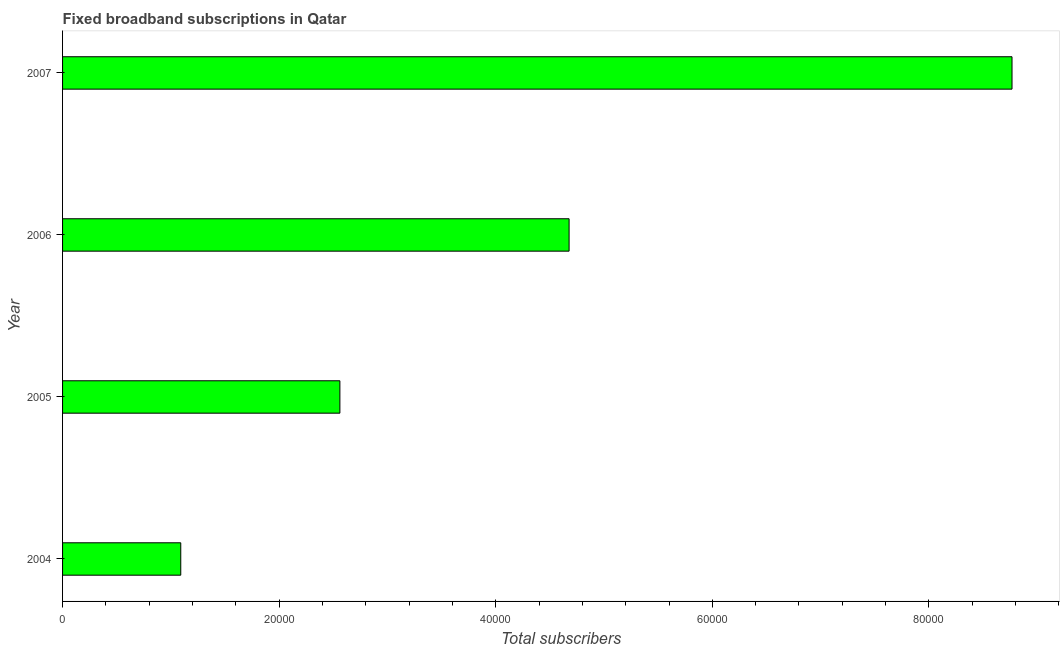Does the graph contain any zero values?
Your answer should be compact. No. Does the graph contain grids?
Keep it short and to the point. No. What is the title of the graph?
Ensure brevity in your answer.  Fixed broadband subscriptions in Qatar. What is the label or title of the X-axis?
Offer a very short reply. Total subscribers. What is the label or title of the Y-axis?
Provide a succinct answer. Year. What is the total number of fixed broadband subscriptions in 2006?
Keep it short and to the point. 4.68e+04. Across all years, what is the maximum total number of fixed broadband subscriptions?
Keep it short and to the point. 8.77e+04. Across all years, what is the minimum total number of fixed broadband subscriptions?
Give a very brief answer. 1.09e+04. What is the sum of the total number of fixed broadband subscriptions?
Offer a terse response. 1.71e+05. What is the difference between the total number of fixed broadband subscriptions in 2005 and 2007?
Provide a short and direct response. -6.21e+04. What is the average total number of fixed broadband subscriptions per year?
Give a very brief answer. 4.27e+04. What is the median total number of fixed broadband subscriptions?
Ensure brevity in your answer.  3.62e+04. In how many years, is the total number of fixed broadband subscriptions greater than 48000 ?
Your response must be concise. 1. Do a majority of the years between 2007 and 2004 (inclusive) have total number of fixed broadband subscriptions greater than 56000 ?
Keep it short and to the point. Yes. What is the ratio of the total number of fixed broadband subscriptions in 2005 to that in 2006?
Your answer should be compact. 0.55. Is the total number of fixed broadband subscriptions in 2004 less than that in 2005?
Give a very brief answer. Yes. What is the difference between the highest and the second highest total number of fixed broadband subscriptions?
Provide a succinct answer. 4.09e+04. What is the difference between the highest and the lowest total number of fixed broadband subscriptions?
Provide a succinct answer. 7.68e+04. In how many years, is the total number of fixed broadband subscriptions greater than the average total number of fixed broadband subscriptions taken over all years?
Your response must be concise. 2. How many bars are there?
Offer a very short reply. 4. Are all the bars in the graph horizontal?
Your answer should be compact. Yes. How many years are there in the graph?
Your answer should be compact. 4. What is the difference between two consecutive major ticks on the X-axis?
Your answer should be compact. 2.00e+04. What is the Total subscribers in 2004?
Make the answer very short. 1.09e+04. What is the Total subscribers in 2005?
Make the answer very short. 2.56e+04. What is the Total subscribers of 2006?
Offer a very short reply. 4.68e+04. What is the Total subscribers in 2007?
Provide a short and direct response. 8.77e+04. What is the difference between the Total subscribers in 2004 and 2005?
Give a very brief answer. -1.47e+04. What is the difference between the Total subscribers in 2004 and 2006?
Make the answer very short. -3.59e+04. What is the difference between the Total subscribers in 2004 and 2007?
Your answer should be very brief. -7.68e+04. What is the difference between the Total subscribers in 2005 and 2006?
Offer a terse response. -2.12e+04. What is the difference between the Total subscribers in 2005 and 2007?
Provide a short and direct response. -6.21e+04. What is the difference between the Total subscribers in 2006 and 2007?
Keep it short and to the point. -4.09e+04. What is the ratio of the Total subscribers in 2004 to that in 2005?
Offer a very short reply. 0.43. What is the ratio of the Total subscribers in 2004 to that in 2006?
Keep it short and to the point. 0.23. What is the ratio of the Total subscribers in 2004 to that in 2007?
Your answer should be very brief. 0.12. What is the ratio of the Total subscribers in 2005 to that in 2006?
Offer a terse response. 0.55. What is the ratio of the Total subscribers in 2005 to that in 2007?
Your answer should be compact. 0.29. What is the ratio of the Total subscribers in 2006 to that in 2007?
Make the answer very short. 0.53. 